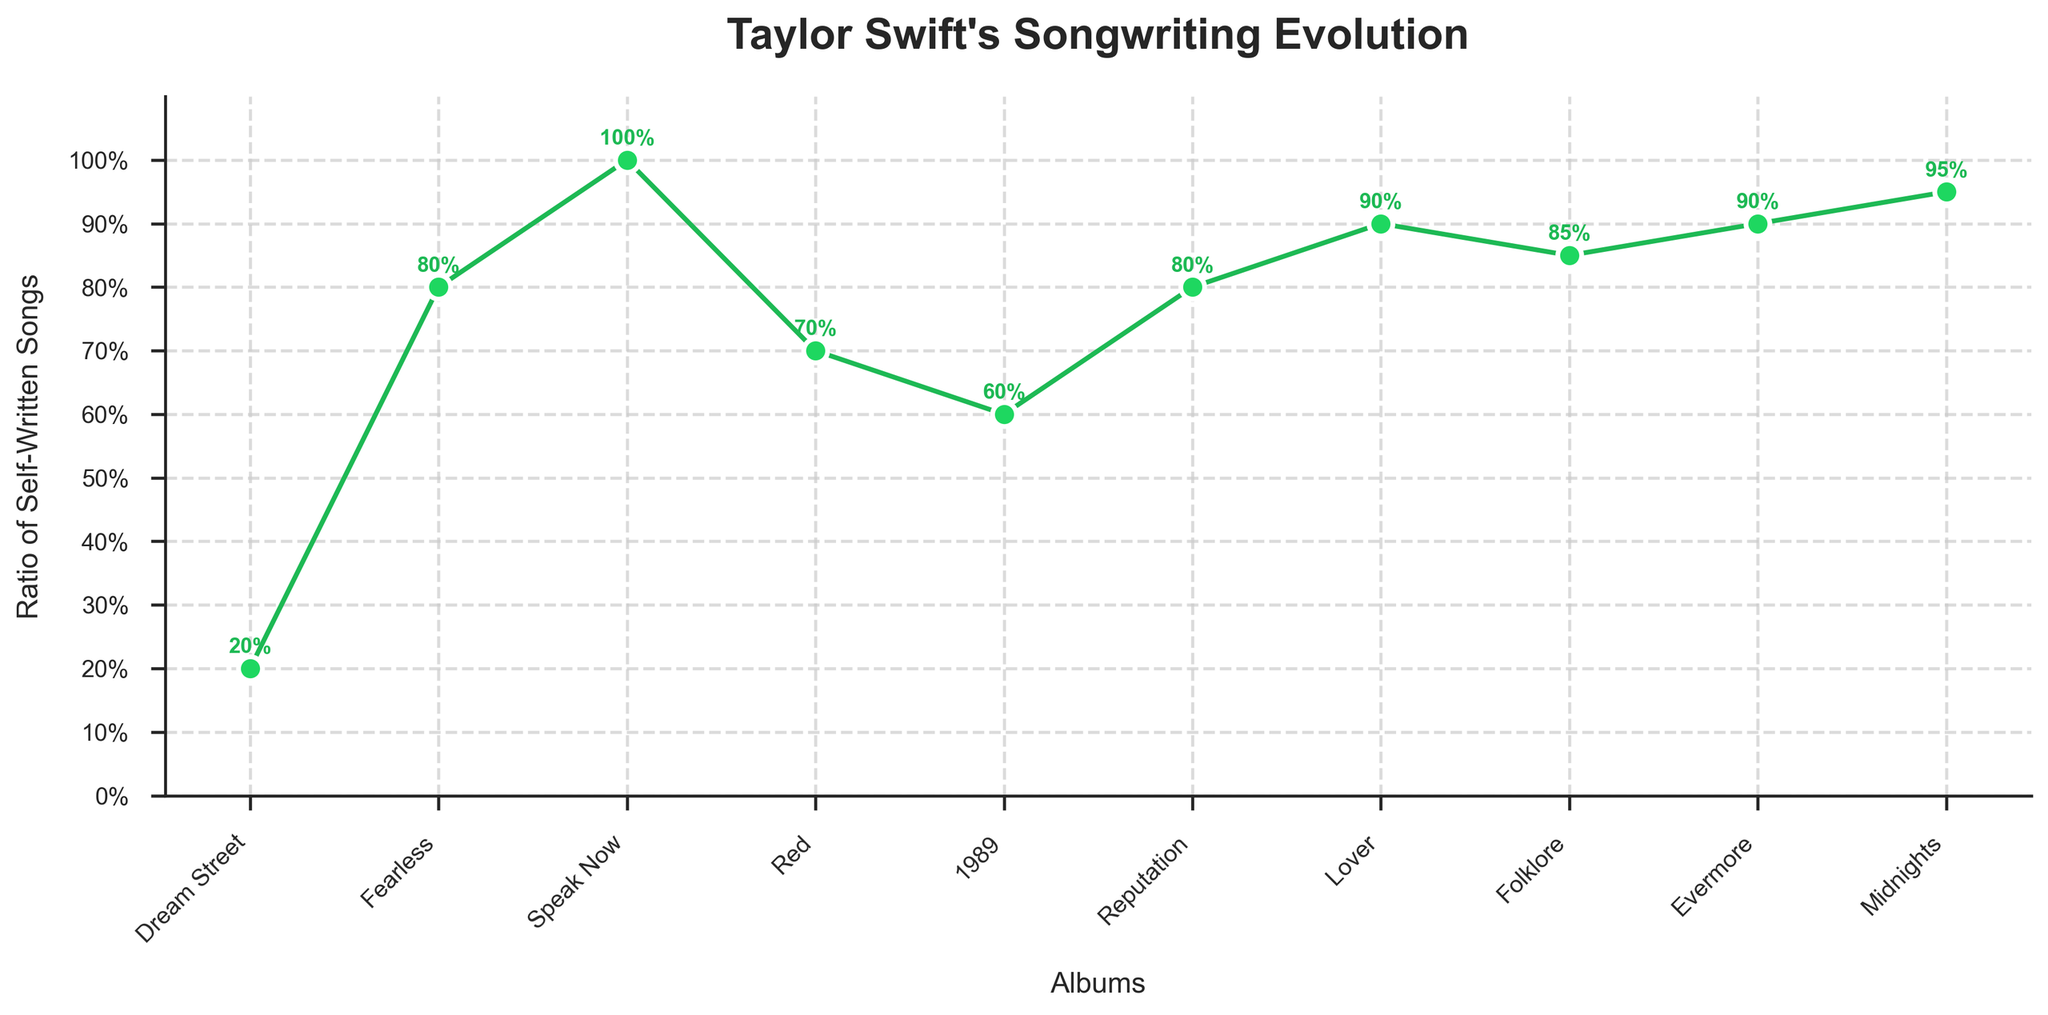What is the ratio of self-written songs on the album "Speak Now"? Refer to the data points on the figure to find the self-written songs ratio for the album "Speak Now". "Speak Now" is displayed with the highest data point, indicating a ratio of 1.0.
Answer: 1.0 Which album has the highest ratio of self-written songs? Look for the highest data point on the chart. "Speak Now" and "Midnights" have the highest position, indicating a ratio of 1.0 and 0.95, respectively.
Answer: "Speak Now" What is the trend in the ratio of self-written songs from "Dream Street" to "Fearless"? Compare the data points for the two albums. The ratio goes from 0.2 in "Dream Street" to 0.8 in "Fearless", showing a significant increase.
Answer: Increasing How does the self-written songs ratio of "1989" compare to "Reputation"? Examine the data points for both albums. "1989" has a ratio of 0.6, while "Reputation" has a higher ratio of 0.8.
Answer: "Reputation" is higher Which albums have a self-written songs ratio greater than 0.8? Look for data points above the 0.8 mark. The albums are "Speak Now" (1.0), "Lover" (0.9), "Folklore" (0.85), "Evermore" (0.9), and "Midnights" (0.95).
Answer: "Speak Now", "Lover", "Folklore", "Evermore", "Midnights" What is the average self-written songs ratio for "Lover", "Folklore", and "Evermore"? Add up the ratios for the three albums (0.9 + 0.85 + 0.9) and divide by 3. The sum is 2.65, so the average ratio is 2.65 / 3 ≈ 0.88.
Answer: 0.88 Compare the ratio of self-written songs on "Red" and "Fearless". What is the difference? Find and subtract the data points: "Red" has a ratio of 0.7, and "Fearless" has a ratio of 0.8. The difference is 0.8 - 0.7 = 0.1.
Answer: 0.1 What was the ratio of self-written songs on the albums released before "1989"? Identify data points for "Dream Street" (0.2), "Fearless" (0.8), "Speak Now" (1.0), and "Red" (0.7). Verify the ratios and note them as 0.2, 0.8, 1.0, and 0.7, respectively.
Answer: 0.2, 0.8, 1.0, 0.7 Is there an album where the ratio of self-written songs remained the same compared to the previous album? Check for consecutive data points with the same value. None remain the same upon inspection.
Answer: No 